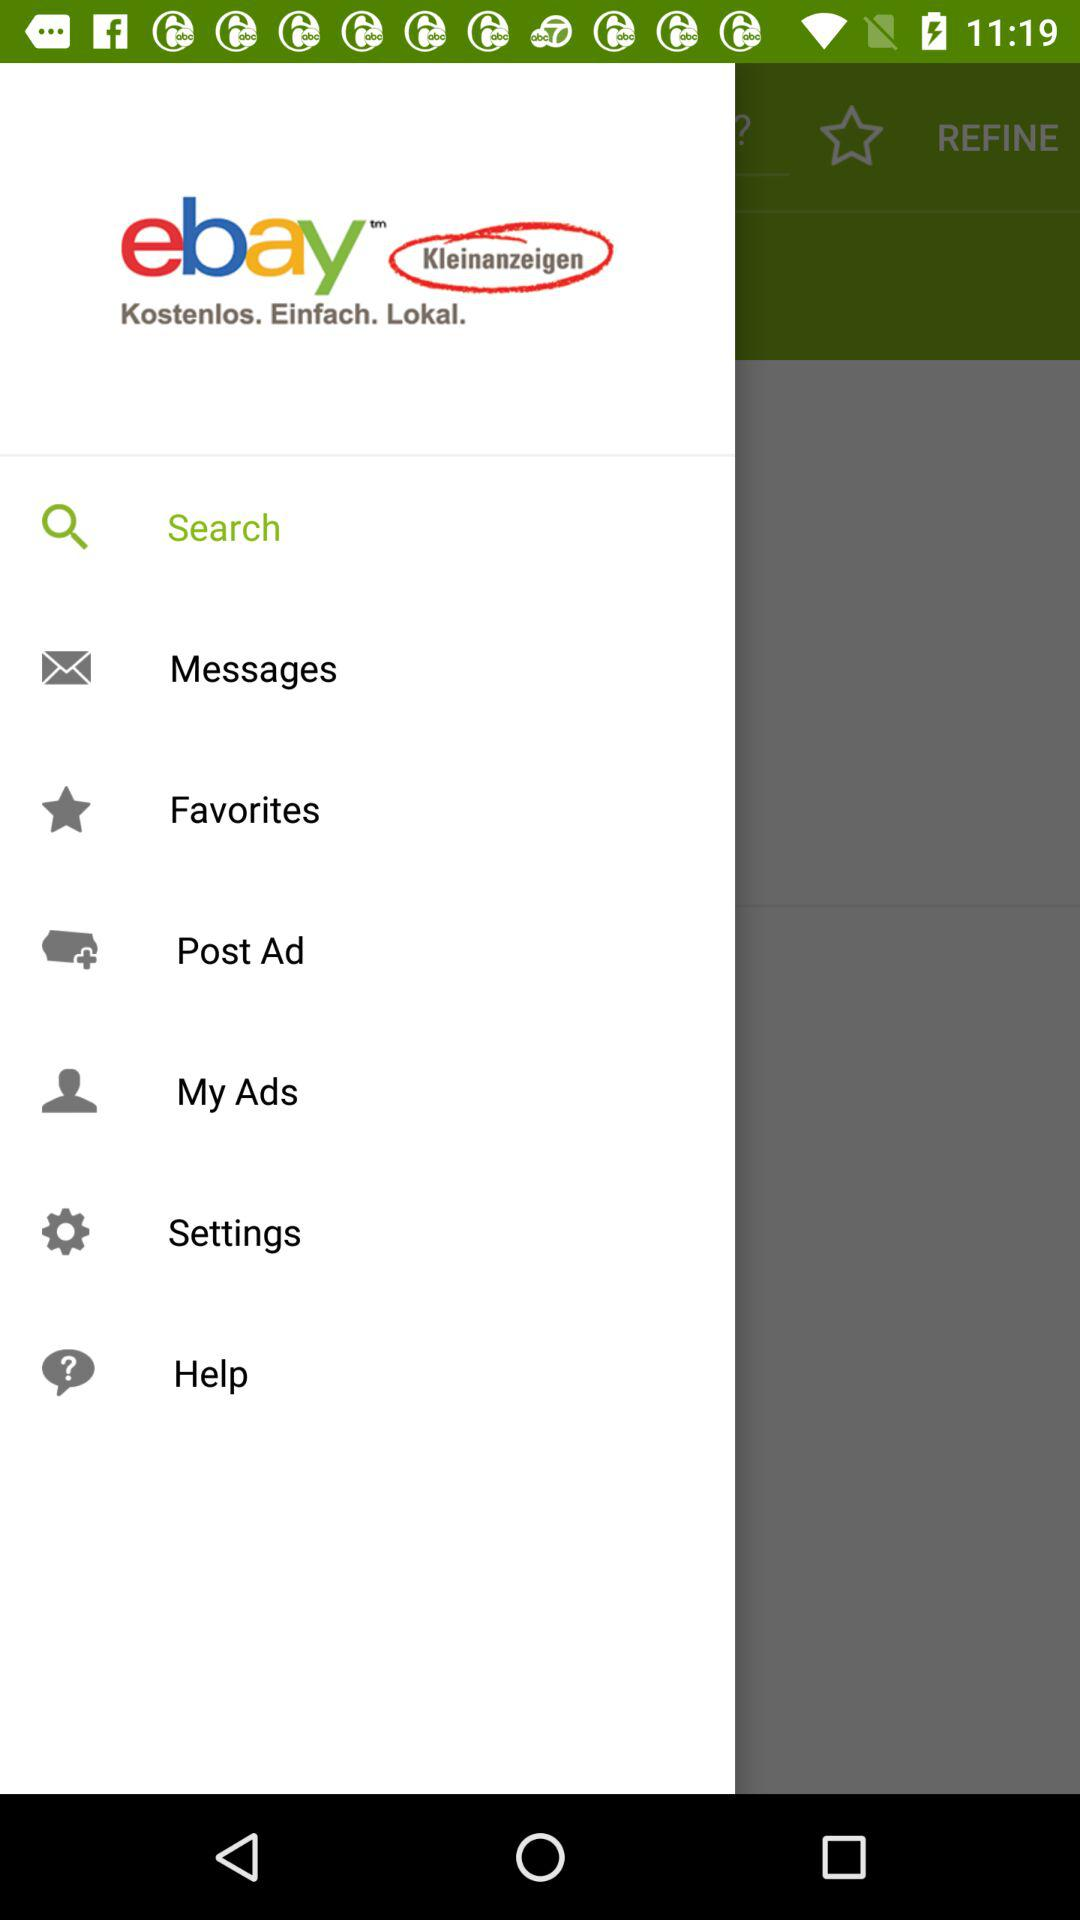What is the application name? The application name is "ebay Kleinanzeigen". 